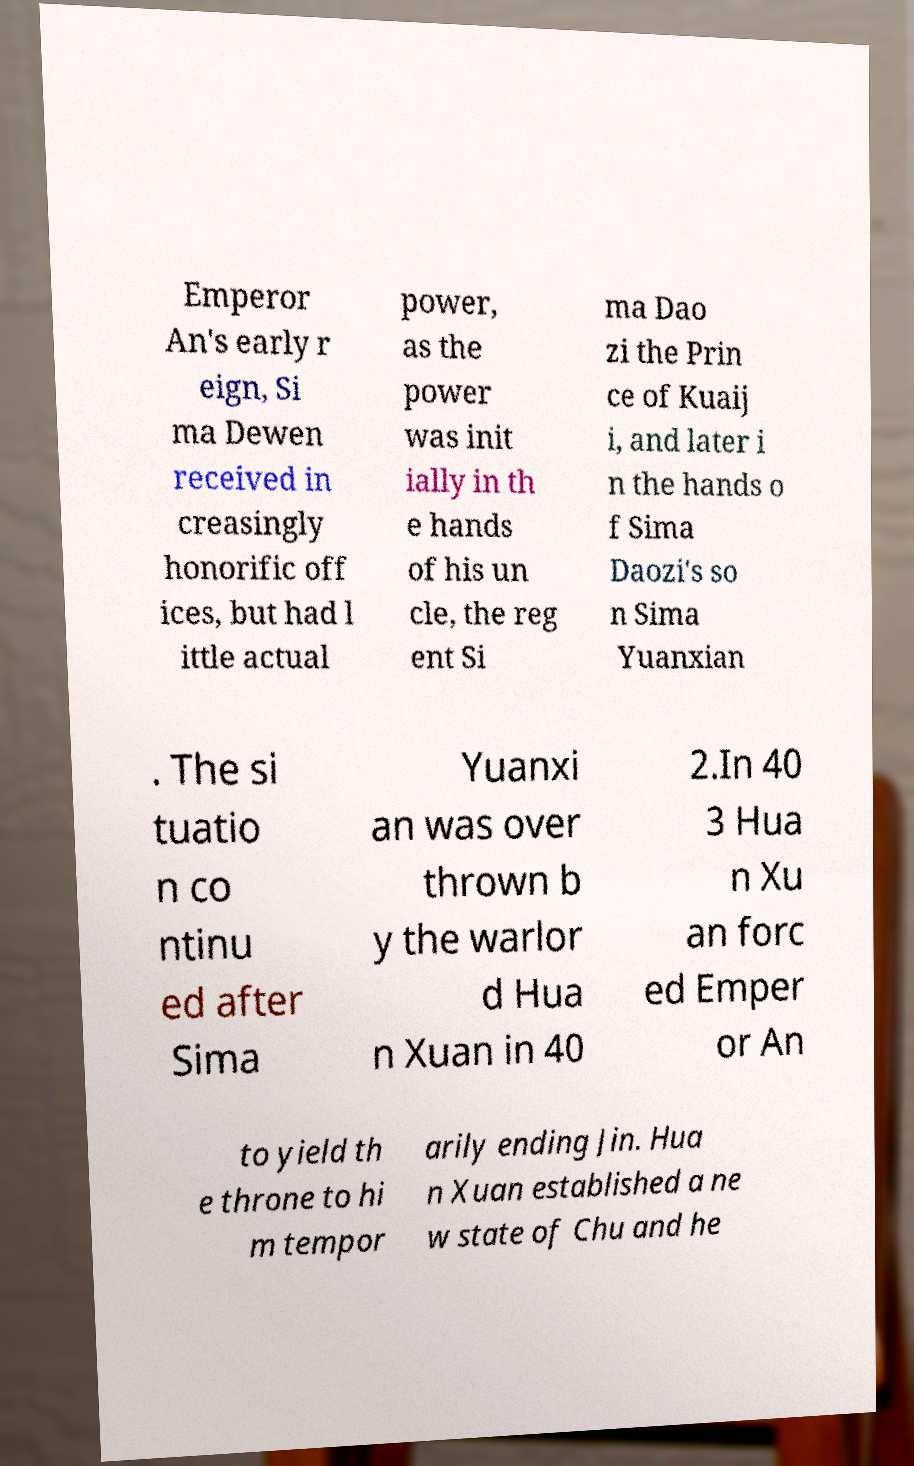Can you read and provide the text displayed in the image?This photo seems to have some interesting text. Can you extract and type it out for me? Emperor An's early r eign, Si ma Dewen received in creasingly honorific off ices, but had l ittle actual power, as the power was init ially in th e hands of his un cle, the reg ent Si ma Dao zi the Prin ce of Kuaij i, and later i n the hands o f Sima Daozi's so n Sima Yuanxian . The si tuatio n co ntinu ed after Sima Yuanxi an was over thrown b y the warlor d Hua n Xuan in 40 2.In 40 3 Hua n Xu an forc ed Emper or An to yield th e throne to hi m tempor arily ending Jin. Hua n Xuan established a ne w state of Chu and he 